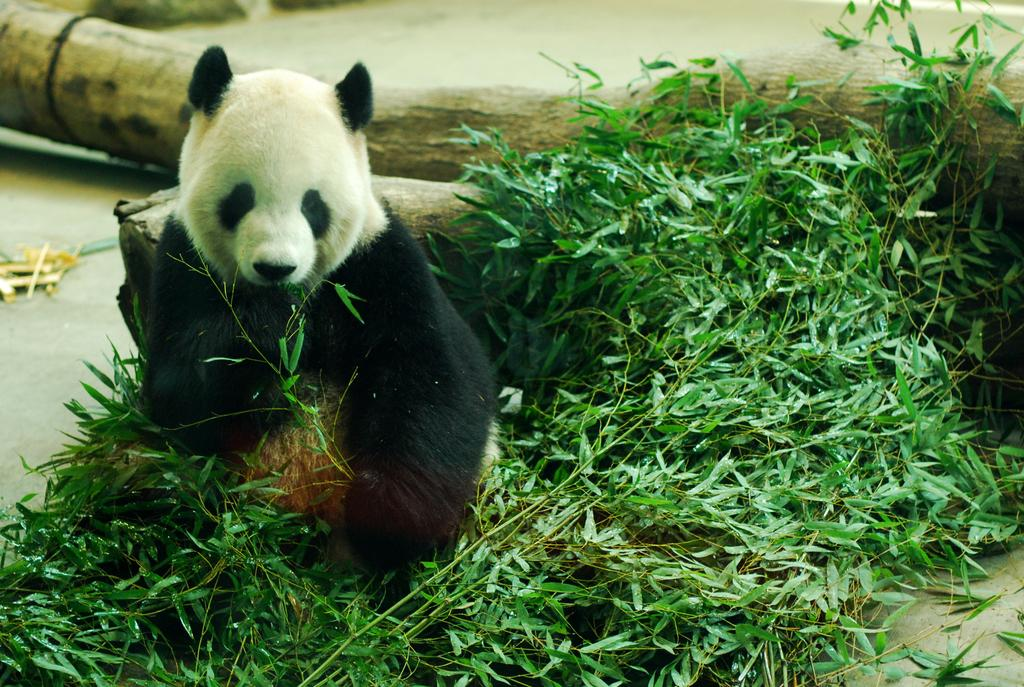What animal is in the picture? There is a bear in the picture. What can be seen in the foreground of the picture? There are plants in the front of the picture. What type of material is visible in the background of the picture? There is wood visible in the background of the picture. What type of fog can be seen in the picture? There is no fog present in the picture; it features a bear, plants, and wood. How are the plants in the picture being sorted? The plants in the picture are not being sorted; they are simply visible in the foreground. 